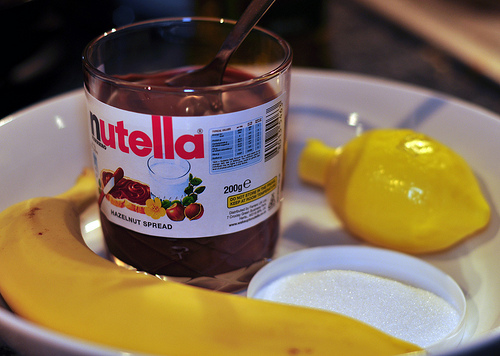<image>
Is there a nutella to the left of the plate? No. The nutella is not to the left of the plate. From this viewpoint, they have a different horizontal relationship. 